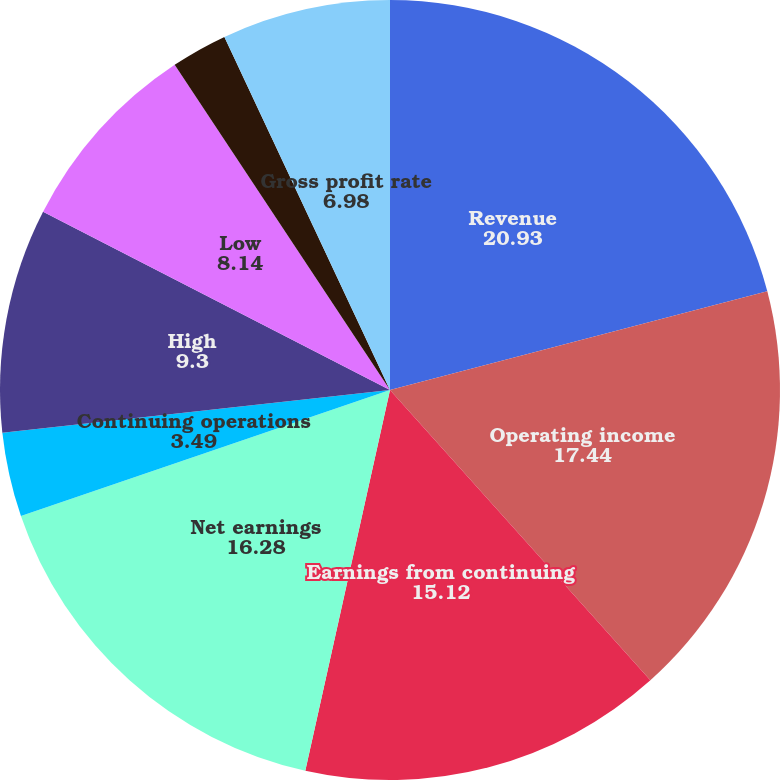<chart> <loc_0><loc_0><loc_500><loc_500><pie_chart><fcel>Revenue<fcel>Operating income<fcel>Earnings from continuing<fcel>Net earnings<fcel>Continuing operations<fcel>Cash dividends declared and<fcel>High<fcel>Low<fcel>Comparable store sales gain<fcel>Gross profit rate<nl><fcel>20.93%<fcel>17.44%<fcel>15.12%<fcel>16.28%<fcel>3.49%<fcel>0.0%<fcel>9.3%<fcel>8.14%<fcel>2.33%<fcel>6.98%<nl></chart> 